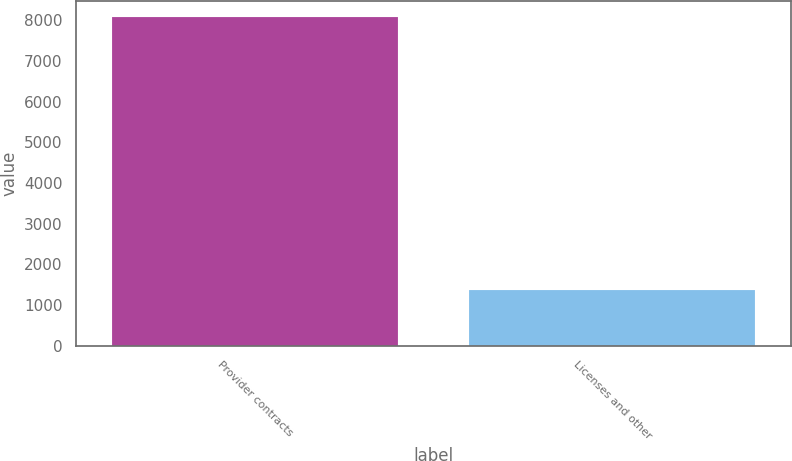Convert chart to OTSL. <chart><loc_0><loc_0><loc_500><loc_500><bar_chart><fcel>Provider contracts<fcel>Licenses and other<nl><fcel>8075<fcel>1376<nl></chart> 